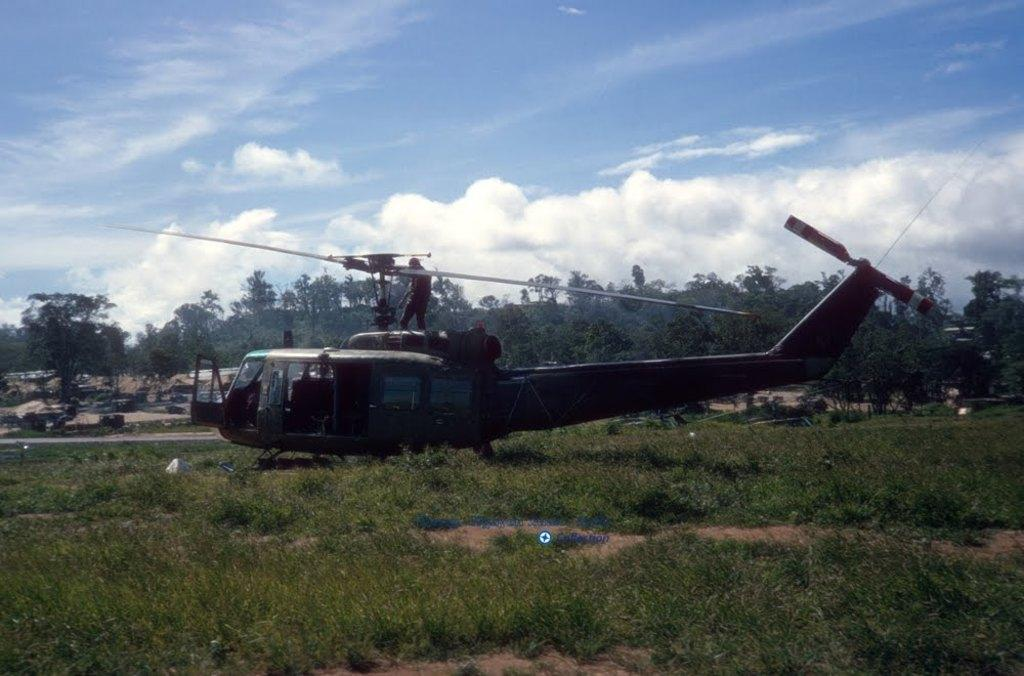What is the main subject of the image? There is an aircraft in the image. Can you describe the person in the image? There is a person standing in the image. What type of vegetation is visible in the background? The background includes grass and trees in green color. How would you describe the sky in the image? The sky is blue and white in the image. What type of oil can be seen flowing through the river in the image? There is no river or oil present in the image. How does the sense of smell contribute to the experience of the person in the image? The image does not provide any information about the person's sense of smell or any related experiences. 